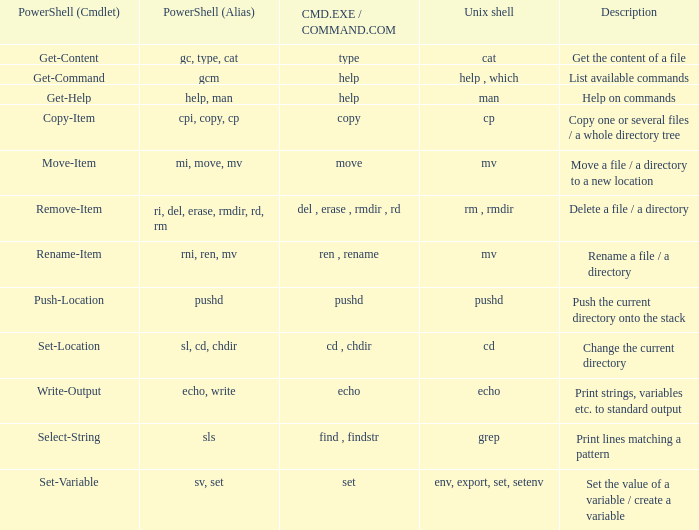How many values of powershell (cmdlet) are valid when unix shell is env, export, set, setenv? 1.0. 